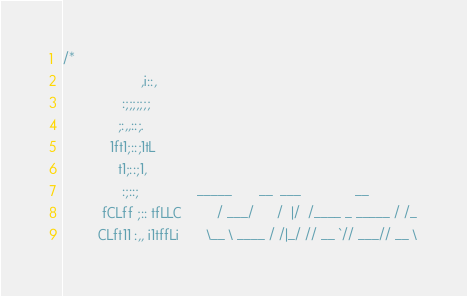Convert code to text. <code><loc_0><loc_0><loc_500><loc_500><_Scala_>/*
                    ,i::,
               :;;;;;;;
              ;:,,::;.
            1ft1;::;1tL
              t1;::;1,
               :;::;               _____       __  ___              __
          fCLff ;:: tfLLC         / ___/      /  |/  /____ _ _____ / /_
         CLft11 :,, i1tffLi       \__ \ ____ / /|_/ // __ `// ___// __ \</code> 